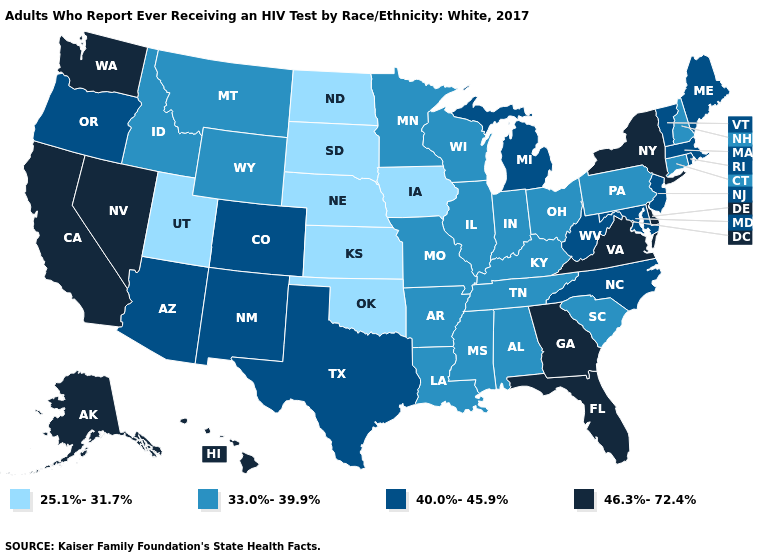What is the highest value in states that border Washington?
Answer briefly. 40.0%-45.9%. Name the states that have a value in the range 40.0%-45.9%?
Answer briefly. Arizona, Colorado, Maine, Maryland, Massachusetts, Michigan, New Jersey, New Mexico, North Carolina, Oregon, Rhode Island, Texas, Vermont, West Virginia. What is the lowest value in states that border New Hampshire?
Give a very brief answer. 40.0%-45.9%. What is the value of Kentucky?
Write a very short answer. 33.0%-39.9%. What is the value of South Dakota?
Give a very brief answer. 25.1%-31.7%. Does the first symbol in the legend represent the smallest category?
Write a very short answer. Yes. Name the states that have a value in the range 40.0%-45.9%?
Be succinct. Arizona, Colorado, Maine, Maryland, Massachusetts, Michigan, New Jersey, New Mexico, North Carolina, Oregon, Rhode Island, Texas, Vermont, West Virginia. What is the value of Montana?
Write a very short answer. 33.0%-39.9%. Name the states that have a value in the range 33.0%-39.9%?
Write a very short answer. Alabama, Arkansas, Connecticut, Idaho, Illinois, Indiana, Kentucky, Louisiana, Minnesota, Mississippi, Missouri, Montana, New Hampshire, Ohio, Pennsylvania, South Carolina, Tennessee, Wisconsin, Wyoming. What is the value of Wyoming?
Give a very brief answer. 33.0%-39.9%. Does Mississippi have the same value as Wyoming?
Be succinct. Yes. Does Louisiana have the highest value in the USA?
Write a very short answer. No. What is the highest value in the West ?
Concise answer only. 46.3%-72.4%. Is the legend a continuous bar?
Give a very brief answer. No. Does South Dakota have the highest value in the MidWest?
Answer briefly. No. 